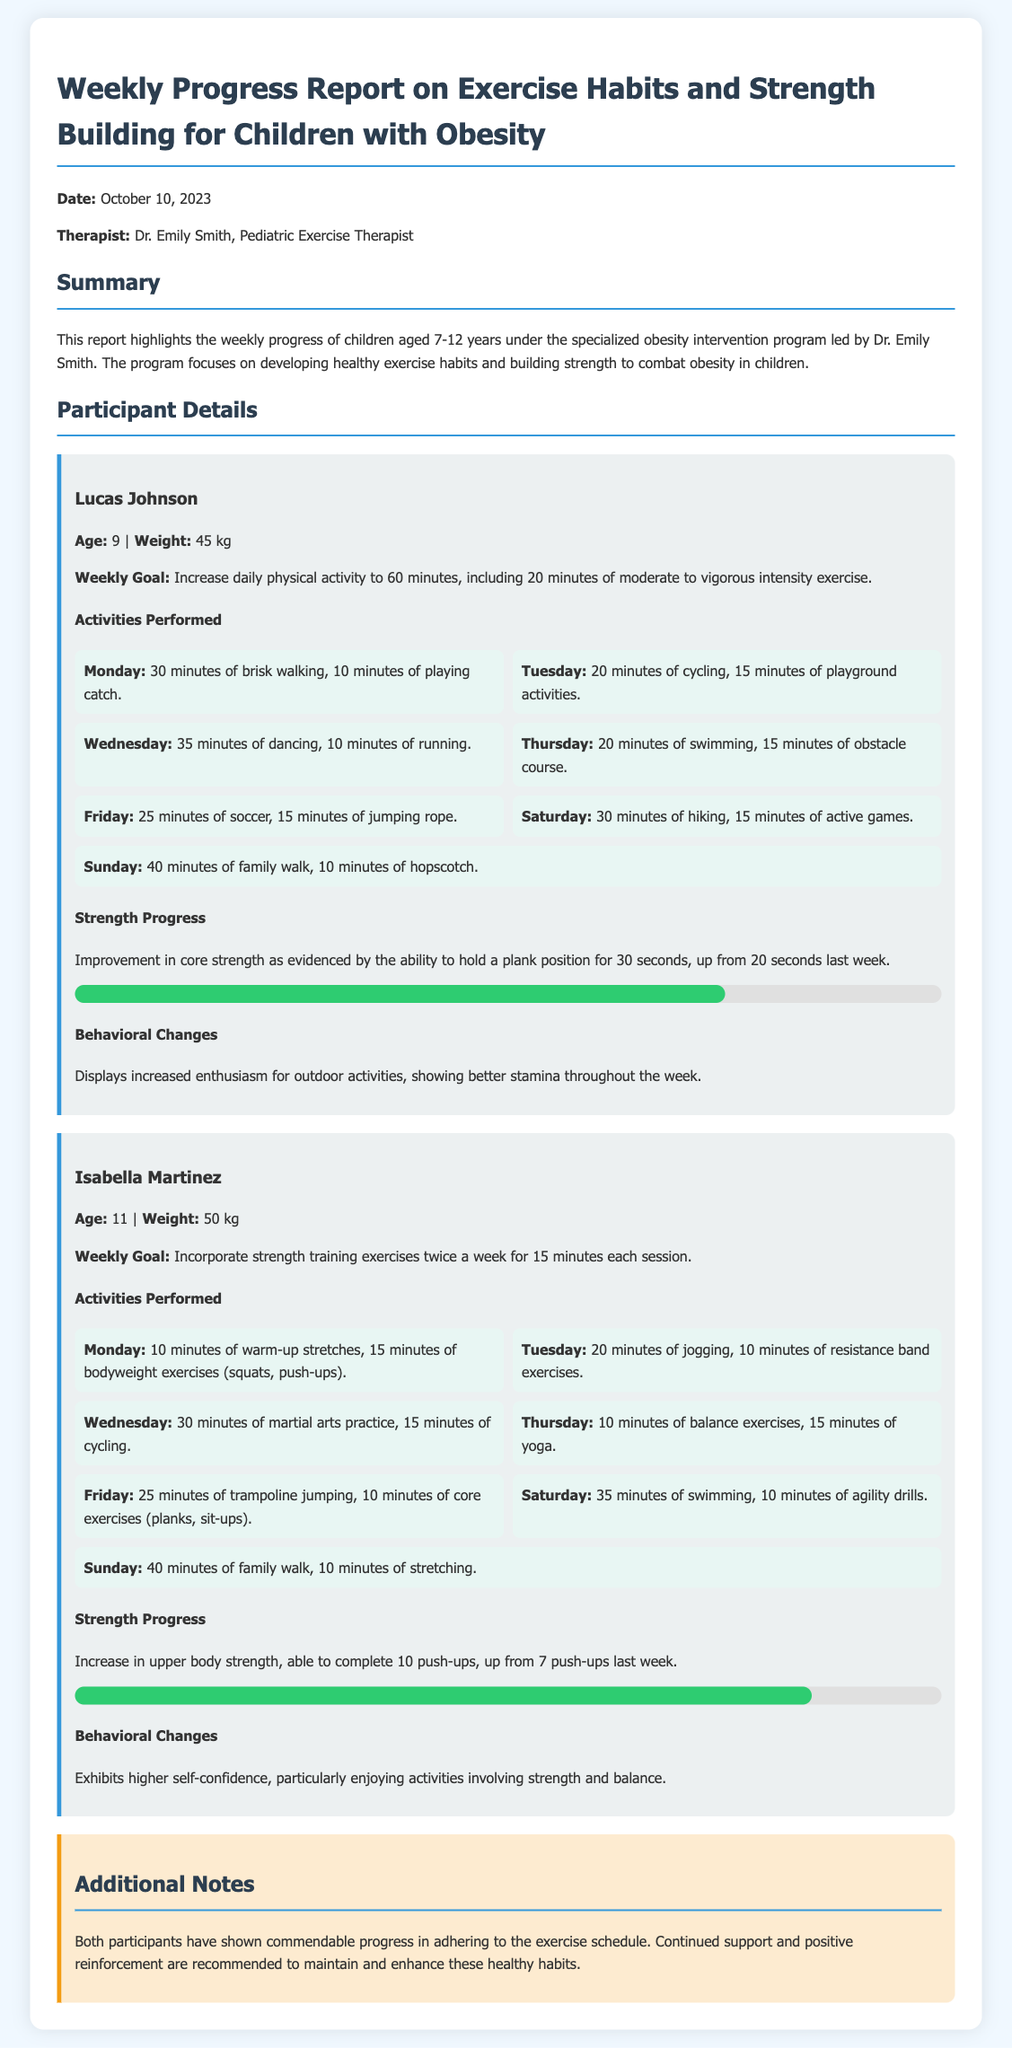What is the date of the report? The report is dated October 10, 2023.
Answer: October 10, 2023 Who is the therapist overseeing the program? The therapist leading the program is Dr. Emily Smith.
Answer: Dr. Emily Smith What is Lucas's weight? Lucas Johnson's weight is mentioned in the report as 45 kg.
Answer: 45 kg How many push-ups can Isabella do now? Isabella has increased her push-up count to 10, up from 7 last week.
Answer: 10 What is the weekly goal for Lucas? Lucas's goal is to increase daily physical activity to 60 minutes.
Answer: 60 minutes Which activity did Isabella perform on Wednesday? On Wednesday, Isabella practiced martial arts for 30 minutes followed by cycling for 15 minutes.
Answer: Martial arts What percentage did Lucas achieve in strength progress? Lucas's strength progress percentage is represented as 75%.
Answer: 75% What behavioral change is noted for Isabella? Isabella exhibits higher self-confidence, particularly in strength and balance activities.
Answer: Higher self-confidence How many minutes did Lucas spend on swimming? Lucas swam for 20 minutes on Thursday.
Answer: 20 minutes 